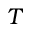Convert formula to latex. <formula><loc_0><loc_0><loc_500><loc_500>T</formula> 